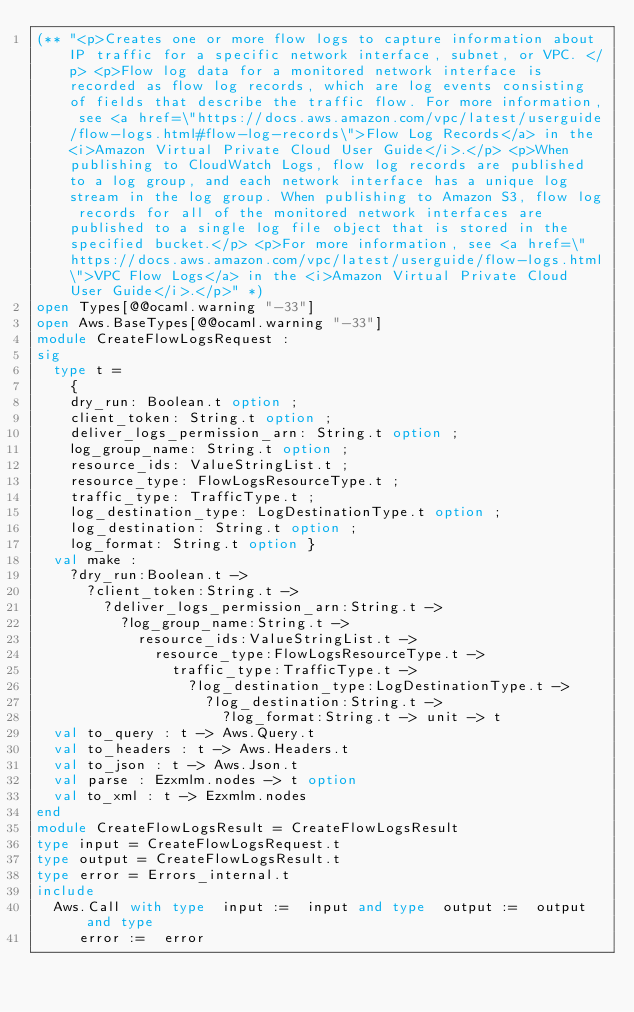Convert code to text. <code><loc_0><loc_0><loc_500><loc_500><_OCaml_>(** "<p>Creates one or more flow logs to capture information about IP traffic for a specific network interface, subnet, or VPC. </p> <p>Flow log data for a monitored network interface is recorded as flow log records, which are log events consisting of fields that describe the traffic flow. For more information, see <a href=\"https://docs.aws.amazon.com/vpc/latest/userguide/flow-logs.html#flow-log-records\">Flow Log Records</a> in the <i>Amazon Virtual Private Cloud User Guide</i>.</p> <p>When publishing to CloudWatch Logs, flow log records are published to a log group, and each network interface has a unique log stream in the log group. When publishing to Amazon S3, flow log records for all of the monitored network interfaces are published to a single log file object that is stored in the specified bucket.</p> <p>For more information, see <a href=\"https://docs.aws.amazon.com/vpc/latest/userguide/flow-logs.html\">VPC Flow Logs</a> in the <i>Amazon Virtual Private Cloud User Guide</i>.</p>" *)
open Types[@@ocaml.warning "-33"]
open Aws.BaseTypes[@@ocaml.warning "-33"]
module CreateFlowLogsRequest :
sig
  type t =
    {
    dry_run: Boolean.t option ;
    client_token: String.t option ;
    deliver_logs_permission_arn: String.t option ;
    log_group_name: String.t option ;
    resource_ids: ValueStringList.t ;
    resource_type: FlowLogsResourceType.t ;
    traffic_type: TrafficType.t ;
    log_destination_type: LogDestinationType.t option ;
    log_destination: String.t option ;
    log_format: String.t option }
  val make :
    ?dry_run:Boolean.t ->
      ?client_token:String.t ->
        ?deliver_logs_permission_arn:String.t ->
          ?log_group_name:String.t ->
            resource_ids:ValueStringList.t ->
              resource_type:FlowLogsResourceType.t ->
                traffic_type:TrafficType.t ->
                  ?log_destination_type:LogDestinationType.t ->
                    ?log_destination:String.t ->
                      ?log_format:String.t -> unit -> t
  val to_query : t -> Aws.Query.t
  val to_headers : t -> Aws.Headers.t
  val to_json : t -> Aws.Json.t
  val parse : Ezxmlm.nodes -> t option
  val to_xml : t -> Ezxmlm.nodes
end
module CreateFlowLogsResult = CreateFlowLogsResult
type input = CreateFlowLogsRequest.t
type output = CreateFlowLogsResult.t
type error = Errors_internal.t
include
  Aws.Call with type  input :=  input and type  output :=  output and type
     error :=  error</code> 